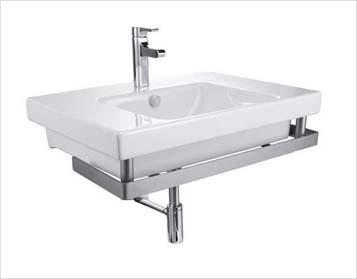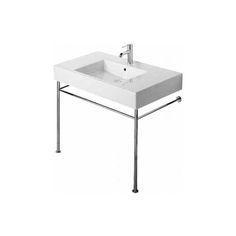The first image is the image on the left, the second image is the image on the right. For the images displayed, is the sentence "One image shows a rectangular sink supported by two metal legs, with a horizontal bar along three sides." factually correct? Answer yes or no. Yes. The first image is the image on the left, the second image is the image on the right. Given the left and right images, does the statement "One sink is round shaped." hold true? Answer yes or no. No. 